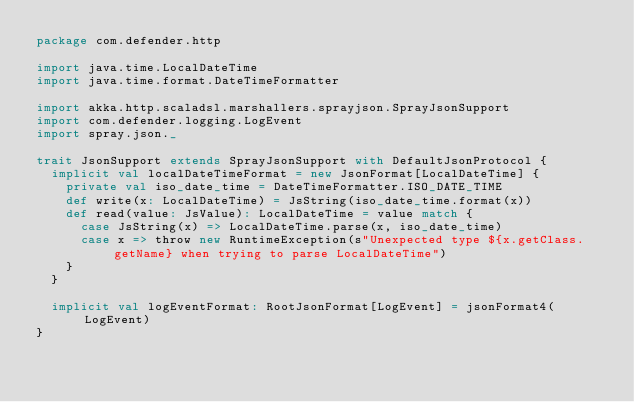<code> <loc_0><loc_0><loc_500><loc_500><_Scala_>package com.defender.http

import java.time.LocalDateTime
import java.time.format.DateTimeFormatter

import akka.http.scaladsl.marshallers.sprayjson.SprayJsonSupport
import com.defender.logging.LogEvent
import spray.json._

trait JsonSupport extends SprayJsonSupport with DefaultJsonProtocol {
  implicit val localDateTimeFormat = new JsonFormat[LocalDateTime] {
    private val iso_date_time = DateTimeFormatter.ISO_DATE_TIME
    def write(x: LocalDateTime) = JsString(iso_date_time.format(x))
    def read(value: JsValue): LocalDateTime = value match {
      case JsString(x) => LocalDateTime.parse(x, iso_date_time)
      case x => throw new RuntimeException(s"Unexpected type ${x.getClass.getName} when trying to parse LocalDateTime")
    }
  }

  implicit val logEventFormat: RootJsonFormat[LogEvent] = jsonFormat4(LogEvent)
}

</code> 